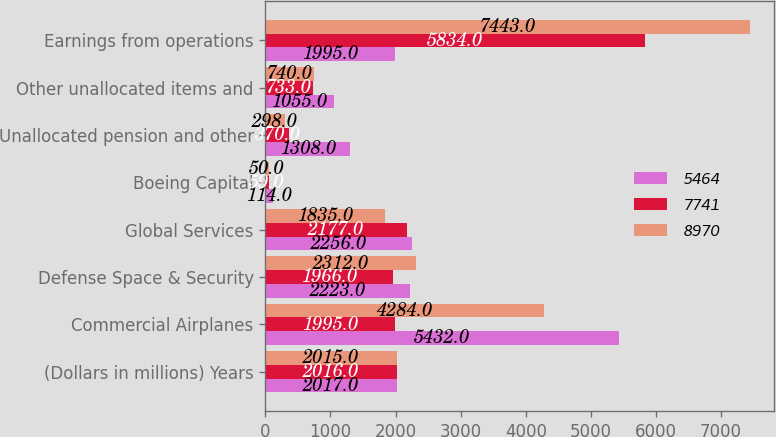Convert chart to OTSL. <chart><loc_0><loc_0><loc_500><loc_500><stacked_bar_chart><ecel><fcel>(Dollars in millions) Years<fcel>Commercial Airplanes<fcel>Defense Space & Security<fcel>Global Services<fcel>Boeing Capital<fcel>Unallocated pension and other<fcel>Other unallocated items and<fcel>Earnings from operations<nl><fcel>5464<fcel>2017<fcel>5432<fcel>2223<fcel>2256<fcel>114<fcel>1308<fcel>1055<fcel>1995<nl><fcel>7741<fcel>2016<fcel>1995<fcel>1966<fcel>2177<fcel>59<fcel>370<fcel>733<fcel>5834<nl><fcel>8970<fcel>2015<fcel>4284<fcel>2312<fcel>1835<fcel>50<fcel>298<fcel>740<fcel>7443<nl></chart> 